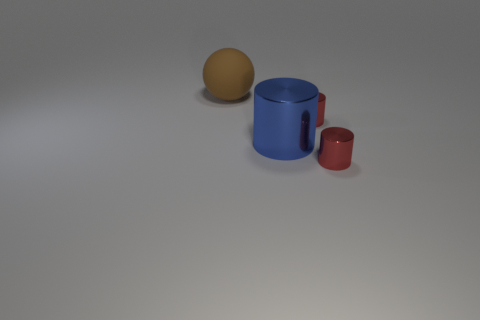Add 2 large metal objects. How many objects exist? 6 Subtract all red cylinders. How many cylinders are left? 1 Subtract all big metal cylinders. How many cylinders are left? 2 Add 1 brown spheres. How many brown spheres exist? 2 Subtract 0 blue cubes. How many objects are left? 4 Subtract all balls. How many objects are left? 3 Subtract 1 spheres. How many spheres are left? 0 Subtract all red cylinders. Subtract all green balls. How many cylinders are left? 1 Subtract all brown balls. How many blue cylinders are left? 1 Subtract all small objects. Subtract all large balls. How many objects are left? 1 